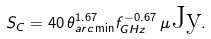<formula> <loc_0><loc_0><loc_500><loc_500>S _ { C } = 4 0 \, \theta _ { a r c \min } ^ { 1 . 6 7 } f ^ { - 0 . 6 7 } _ { G H z } \, \mu \text {Jy} .</formula> 